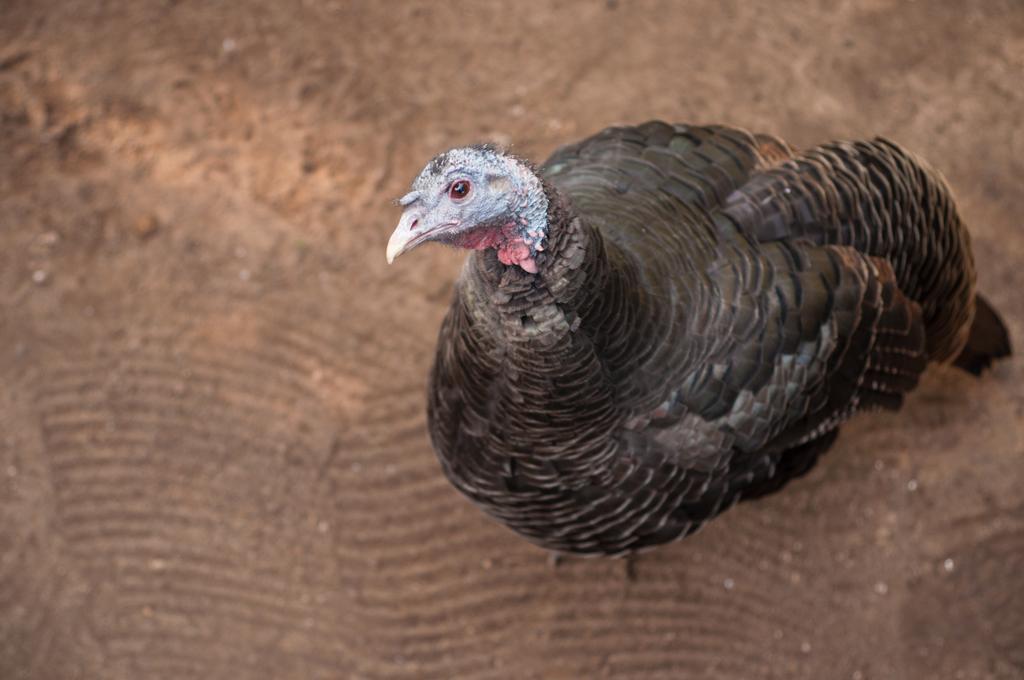Could you give a brief overview of what you see in this image? In the picture we can see a bird which is in black color. 